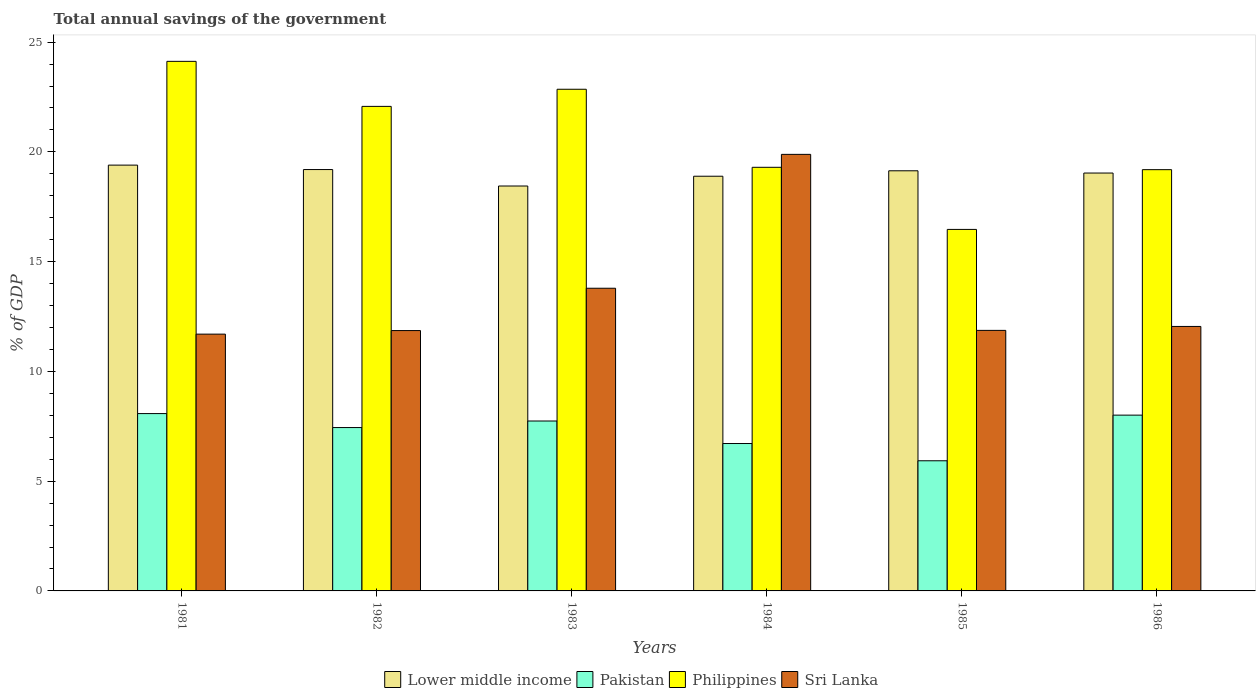How many groups of bars are there?
Give a very brief answer. 6. How many bars are there on the 6th tick from the left?
Ensure brevity in your answer.  4. How many bars are there on the 4th tick from the right?
Provide a short and direct response. 4. What is the label of the 1st group of bars from the left?
Your response must be concise. 1981. What is the total annual savings of the government in Philippines in 1985?
Your response must be concise. 16.47. Across all years, what is the maximum total annual savings of the government in Lower middle income?
Provide a succinct answer. 19.4. Across all years, what is the minimum total annual savings of the government in Philippines?
Your response must be concise. 16.47. In which year was the total annual savings of the government in Sri Lanka maximum?
Your answer should be compact. 1984. What is the total total annual savings of the government in Philippines in the graph?
Provide a short and direct response. 124.01. What is the difference between the total annual savings of the government in Pakistan in 1981 and that in 1985?
Provide a short and direct response. 2.15. What is the difference between the total annual savings of the government in Sri Lanka in 1986 and the total annual savings of the government in Philippines in 1983?
Your answer should be very brief. -10.8. What is the average total annual savings of the government in Philippines per year?
Give a very brief answer. 20.67. In the year 1986, what is the difference between the total annual savings of the government in Lower middle income and total annual savings of the government in Pakistan?
Your response must be concise. 11.03. In how many years, is the total annual savings of the government in Sri Lanka greater than 6 %?
Offer a very short reply. 6. What is the ratio of the total annual savings of the government in Philippines in 1981 to that in 1982?
Your answer should be very brief. 1.09. Is the total annual savings of the government in Philippines in 1983 less than that in 1986?
Your answer should be compact. No. Is the difference between the total annual savings of the government in Lower middle income in 1982 and 1984 greater than the difference between the total annual savings of the government in Pakistan in 1982 and 1984?
Provide a short and direct response. No. What is the difference between the highest and the second highest total annual savings of the government in Philippines?
Offer a very short reply. 1.27. What is the difference between the highest and the lowest total annual savings of the government in Sri Lanka?
Your response must be concise. 8.19. Is the sum of the total annual savings of the government in Pakistan in 1982 and 1984 greater than the maximum total annual savings of the government in Philippines across all years?
Your answer should be very brief. No. Is it the case that in every year, the sum of the total annual savings of the government in Pakistan and total annual savings of the government in Lower middle income is greater than the sum of total annual savings of the government in Sri Lanka and total annual savings of the government in Philippines?
Make the answer very short. Yes. What does the 3rd bar from the left in 1984 represents?
Offer a very short reply. Philippines. What does the 4th bar from the right in 1985 represents?
Provide a short and direct response. Lower middle income. How many years are there in the graph?
Make the answer very short. 6. Does the graph contain any zero values?
Offer a terse response. No. Where does the legend appear in the graph?
Offer a terse response. Bottom center. How are the legend labels stacked?
Provide a short and direct response. Horizontal. What is the title of the graph?
Ensure brevity in your answer.  Total annual savings of the government. What is the label or title of the Y-axis?
Keep it short and to the point. % of GDP. What is the % of GDP of Lower middle income in 1981?
Provide a succinct answer. 19.4. What is the % of GDP in Pakistan in 1981?
Make the answer very short. 8.08. What is the % of GDP of Philippines in 1981?
Provide a succinct answer. 24.12. What is the % of GDP in Sri Lanka in 1981?
Offer a terse response. 11.7. What is the % of GDP of Lower middle income in 1982?
Keep it short and to the point. 19.2. What is the % of GDP in Pakistan in 1982?
Give a very brief answer. 7.44. What is the % of GDP in Philippines in 1982?
Provide a succinct answer. 22.07. What is the % of GDP in Sri Lanka in 1982?
Provide a short and direct response. 11.86. What is the % of GDP in Lower middle income in 1983?
Your response must be concise. 18.45. What is the % of GDP of Pakistan in 1983?
Offer a terse response. 7.74. What is the % of GDP of Philippines in 1983?
Give a very brief answer. 22.85. What is the % of GDP in Sri Lanka in 1983?
Offer a very short reply. 13.79. What is the % of GDP in Lower middle income in 1984?
Offer a very short reply. 18.89. What is the % of GDP in Pakistan in 1984?
Give a very brief answer. 6.71. What is the % of GDP of Philippines in 1984?
Give a very brief answer. 19.3. What is the % of GDP of Sri Lanka in 1984?
Make the answer very short. 19.89. What is the % of GDP of Lower middle income in 1985?
Ensure brevity in your answer.  19.14. What is the % of GDP in Pakistan in 1985?
Keep it short and to the point. 5.93. What is the % of GDP of Philippines in 1985?
Offer a terse response. 16.47. What is the % of GDP of Sri Lanka in 1985?
Provide a succinct answer. 11.87. What is the % of GDP of Lower middle income in 1986?
Give a very brief answer. 19.04. What is the % of GDP of Pakistan in 1986?
Make the answer very short. 8.01. What is the % of GDP in Philippines in 1986?
Provide a succinct answer. 19.19. What is the % of GDP in Sri Lanka in 1986?
Make the answer very short. 12.05. Across all years, what is the maximum % of GDP in Lower middle income?
Provide a succinct answer. 19.4. Across all years, what is the maximum % of GDP of Pakistan?
Offer a very short reply. 8.08. Across all years, what is the maximum % of GDP of Philippines?
Your answer should be compact. 24.12. Across all years, what is the maximum % of GDP of Sri Lanka?
Provide a short and direct response. 19.89. Across all years, what is the minimum % of GDP of Lower middle income?
Offer a terse response. 18.45. Across all years, what is the minimum % of GDP of Pakistan?
Keep it short and to the point. 5.93. Across all years, what is the minimum % of GDP of Philippines?
Your response must be concise. 16.47. Across all years, what is the minimum % of GDP of Sri Lanka?
Your answer should be compact. 11.7. What is the total % of GDP in Lower middle income in the graph?
Give a very brief answer. 114.11. What is the total % of GDP in Pakistan in the graph?
Keep it short and to the point. 43.91. What is the total % of GDP in Philippines in the graph?
Provide a short and direct response. 124.01. What is the total % of GDP of Sri Lanka in the graph?
Your response must be concise. 81.15. What is the difference between the % of GDP of Lower middle income in 1981 and that in 1982?
Provide a short and direct response. 0.2. What is the difference between the % of GDP of Pakistan in 1981 and that in 1982?
Keep it short and to the point. 0.64. What is the difference between the % of GDP in Philippines in 1981 and that in 1982?
Your answer should be very brief. 2.05. What is the difference between the % of GDP in Sri Lanka in 1981 and that in 1982?
Keep it short and to the point. -0.16. What is the difference between the % of GDP in Lower middle income in 1981 and that in 1983?
Your response must be concise. 0.95. What is the difference between the % of GDP of Pakistan in 1981 and that in 1983?
Give a very brief answer. 0.34. What is the difference between the % of GDP in Philippines in 1981 and that in 1983?
Give a very brief answer. 1.27. What is the difference between the % of GDP of Sri Lanka in 1981 and that in 1983?
Your answer should be compact. -2.09. What is the difference between the % of GDP of Lower middle income in 1981 and that in 1984?
Give a very brief answer. 0.51. What is the difference between the % of GDP of Pakistan in 1981 and that in 1984?
Offer a very short reply. 1.36. What is the difference between the % of GDP of Philippines in 1981 and that in 1984?
Give a very brief answer. 4.83. What is the difference between the % of GDP in Sri Lanka in 1981 and that in 1984?
Keep it short and to the point. -8.19. What is the difference between the % of GDP in Lower middle income in 1981 and that in 1985?
Offer a terse response. 0.26. What is the difference between the % of GDP of Pakistan in 1981 and that in 1985?
Provide a short and direct response. 2.15. What is the difference between the % of GDP in Philippines in 1981 and that in 1985?
Your answer should be compact. 7.66. What is the difference between the % of GDP in Sri Lanka in 1981 and that in 1985?
Ensure brevity in your answer.  -0.17. What is the difference between the % of GDP in Lower middle income in 1981 and that in 1986?
Keep it short and to the point. 0.36. What is the difference between the % of GDP of Pakistan in 1981 and that in 1986?
Offer a very short reply. 0.07. What is the difference between the % of GDP of Philippines in 1981 and that in 1986?
Your answer should be compact. 4.93. What is the difference between the % of GDP of Sri Lanka in 1981 and that in 1986?
Your answer should be very brief. -0.35. What is the difference between the % of GDP of Lower middle income in 1982 and that in 1983?
Ensure brevity in your answer.  0.75. What is the difference between the % of GDP in Pakistan in 1982 and that in 1983?
Your answer should be very brief. -0.3. What is the difference between the % of GDP of Philippines in 1982 and that in 1983?
Provide a succinct answer. -0.78. What is the difference between the % of GDP of Sri Lanka in 1982 and that in 1983?
Give a very brief answer. -1.93. What is the difference between the % of GDP in Lower middle income in 1982 and that in 1984?
Offer a very short reply. 0.3. What is the difference between the % of GDP of Pakistan in 1982 and that in 1984?
Make the answer very short. 0.73. What is the difference between the % of GDP of Philippines in 1982 and that in 1984?
Offer a very short reply. 2.78. What is the difference between the % of GDP in Sri Lanka in 1982 and that in 1984?
Give a very brief answer. -8.03. What is the difference between the % of GDP in Lower middle income in 1982 and that in 1985?
Ensure brevity in your answer.  0.06. What is the difference between the % of GDP of Pakistan in 1982 and that in 1985?
Offer a terse response. 1.51. What is the difference between the % of GDP of Philippines in 1982 and that in 1985?
Offer a very short reply. 5.6. What is the difference between the % of GDP of Sri Lanka in 1982 and that in 1985?
Provide a short and direct response. -0.01. What is the difference between the % of GDP in Lower middle income in 1982 and that in 1986?
Offer a terse response. 0.16. What is the difference between the % of GDP in Pakistan in 1982 and that in 1986?
Keep it short and to the point. -0.57. What is the difference between the % of GDP in Philippines in 1982 and that in 1986?
Your response must be concise. 2.88. What is the difference between the % of GDP in Sri Lanka in 1982 and that in 1986?
Provide a short and direct response. -0.19. What is the difference between the % of GDP in Lower middle income in 1983 and that in 1984?
Offer a terse response. -0.45. What is the difference between the % of GDP in Pakistan in 1983 and that in 1984?
Your answer should be compact. 1.03. What is the difference between the % of GDP in Philippines in 1983 and that in 1984?
Offer a terse response. 3.56. What is the difference between the % of GDP of Sri Lanka in 1983 and that in 1984?
Provide a succinct answer. -6.1. What is the difference between the % of GDP in Lower middle income in 1983 and that in 1985?
Your answer should be very brief. -0.69. What is the difference between the % of GDP of Pakistan in 1983 and that in 1985?
Offer a terse response. 1.81. What is the difference between the % of GDP of Philippines in 1983 and that in 1985?
Keep it short and to the point. 6.38. What is the difference between the % of GDP in Sri Lanka in 1983 and that in 1985?
Give a very brief answer. 1.92. What is the difference between the % of GDP of Lower middle income in 1983 and that in 1986?
Your response must be concise. -0.59. What is the difference between the % of GDP in Pakistan in 1983 and that in 1986?
Your answer should be very brief. -0.27. What is the difference between the % of GDP in Philippines in 1983 and that in 1986?
Offer a terse response. 3.66. What is the difference between the % of GDP of Sri Lanka in 1983 and that in 1986?
Ensure brevity in your answer.  1.74. What is the difference between the % of GDP in Lower middle income in 1984 and that in 1985?
Keep it short and to the point. -0.25. What is the difference between the % of GDP in Pakistan in 1984 and that in 1985?
Offer a very short reply. 0.79. What is the difference between the % of GDP of Philippines in 1984 and that in 1985?
Provide a succinct answer. 2.83. What is the difference between the % of GDP in Sri Lanka in 1984 and that in 1985?
Your answer should be very brief. 8.02. What is the difference between the % of GDP of Lower middle income in 1984 and that in 1986?
Provide a succinct answer. -0.14. What is the difference between the % of GDP of Pakistan in 1984 and that in 1986?
Ensure brevity in your answer.  -1.29. What is the difference between the % of GDP in Philippines in 1984 and that in 1986?
Give a very brief answer. 0.11. What is the difference between the % of GDP of Sri Lanka in 1984 and that in 1986?
Your response must be concise. 7.84. What is the difference between the % of GDP of Lower middle income in 1985 and that in 1986?
Make the answer very short. 0.1. What is the difference between the % of GDP in Pakistan in 1985 and that in 1986?
Offer a very short reply. -2.08. What is the difference between the % of GDP in Philippines in 1985 and that in 1986?
Give a very brief answer. -2.72. What is the difference between the % of GDP in Sri Lanka in 1985 and that in 1986?
Ensure brevity in your answer.  -0.18. What is the difference between the % of GDP of Lower middle income in 1981 and the % of GDP of Pakistan in 1982?
Give a very brief answer. 11.96. What is the difference between the % of GDP in Lower middle income in 1981 and the % of GDP in Philippines in 1982?
Give a very brief answer. -2.68. What is the difference between the % of GDP of Lower middle income in 1981 and the % of GDP of Sri Lanka in 1982?
Your response must be concise. 7.54. What is the difference between the % of GDP of Pakistan in 1981 and the % of GDP of Philippines in 1982?
Your answer should be compact. -13.99. What is the difference between the % of GDP in Pakistan in 1981 and the % of GDP in Sri Lanka in 1982?
Make the answer very short. -3.78. What is the difference between the % of GDP of Philippines in 1981 and the % of GDP of Sri Lanka in 1982?
Keep it short and to the point. 12.26. What is the difference between the % of GDP in Lower middle income in 1981 and the % of GDP in Pakistan in 1983?
Make the answer very short. 11.66. What is the difference between the % of GDP in Lower middle income in 1981 and the % of GDP in Philippines in 1983?
Provide a succinct answer. -3.46. What is the difference between the % of GDP of Lower middle income in 1981 and the % of GDP of Sri Lanka in 1983?
Provide a short and direct response. 5.61. What is the difference between the % of GDP in Pakistan in 1981 and the % of GDP in Philippines in 1983?
Offer a terse response. -14.77. What is the difference between the % of GDP of Pakistan in 1981 and the % of GDP of Sri Lanka in 1983?
Your answer should be compact. -5.71. What is the difference between the % of GDP in Philippines in 1981 and the % of GDP in Sri Lanka in 1983?
Your response must be concise. 10.34. What is the difference between the % of GDP in Lower middle income in 1981 and the % of GDP in Pakistan in 1984?
Provide a short and direct response. 12.68. What is the difference between the % of GDP of Lower middle income in 1981 and the % of GDP of Philippines in 1984?
Keep it short and to the point. 0.1. What is the difference between the % of GDP in Lower middle income in 1981 and the % of GDP in Sri Lanka in 1984?
Ensure brevity in your answer.  -0.49. What is the difference between the % of GDP in Pakistan in 1981 and the % of GDP in Philippines in 1984?
Provide a short and direct response. -11.22. What is the difference between the % of GDP of Pakistan in 1981 and the % of GDP of Sri Lanka in 1984?
Your answer should be compact. -11.81. What is the difference between the % of GDP of Philippines in 1981 and the % of GDP of Sri Lanka in 1984?
Your response must be concise. 4.24. What is the difference between the % of GDP of Lower middle income in 1981 and the % of GDP of Pakistan in 1985?
Your response must be concise. 13.47. What is the difference between the % of GDP in Lower middle income in 1981 and the % of GDP in Philippines in 1985?
Offer a very short reply. 2.93. What is the difference between the % of GDP in Lower middle income in 1981 and the % of GDP in Sri Lanka in 1985?
Provide a succinct answer. 7.53. What is the difference between the % of GDP of Pakistan in 1981 and the % of GDP of Philippines in 1985?
Keep it short and to the point. -8.39. What is the difference between the % of GDP in Pakistan in 1981 and the % of GDP in Sri Lanka in 1985?
Offer a terse response. -3.79. What is the difference between the % of GDP in Philippines in 1981 and the % of GDP in Sri Lanka in 1985?
Provide a short and direct response. 12.26. What is the difference between the % of GDP in Lower middle income in 1981 and the % of GDP in Pakistan in 1986?
Your response must be concise. 11.39. What is the difference between the % of GDP in Lower middle income in 1981 and the % of GDP in Philippines in 1986?
Offer a terse response. 0.21. What is the difference between the % of GDP of Lower middle income in 1981 and the % of GDP of Sri Lanka in 1986?
Your answer should be compact. 7.35. What is the difference between the % of GDP of Pakistan in 1981 and the % of GDP of Philippines in 1986?
Your answer should be compact. -11.11. What is the difference between the % of GDP of Pakistan in 1981 and the % of GDP of Sri Lanka in 1986?
Provide a short and direct response. -3.97. What is the difference between the % of GDP in Philippines in 1981 and the % of GDP in Sri Lanka in 1986?
Offer a terse response. 12.08. What is the difference between the % of GDP in Lower middle income in 1982 and the % of GDP in Pakistan in 1983?
Your answer should be very brief. 11.46. What is the difference between the % of GDP of Lower middle income in 1982 and the % of GDP of Philippines in 1983?
Your answer should be compact. -3.66. What is the difference between the % of GDP of Lower middle income in 1982 and the % of GDP of Sri Lanka in 1983?
Offer a very short reply. 5.41. What is the difference between the % of GDP of Pakistan in 1982 and the % of GDP of Philippines in 1983?
Your answer should be very brief. -15.41. What is the difference between the % of GDP of Pakistan in 1982 and the % of GDP of Sri Lanka in 1983?
Your response must be concise. -6.35. What is the difference between the % of GDP of Philippines in 1982 and the % of GDP of Sri Lanka in 1983?
Provide a succinct answer. 8.29. What is the difference between the % of GDP of Lower middle income in 1982 and the % of GDP of Pakistan in 1984?
Offer a very short reply. 12.48. What is the difference between the % of GDP of Lower middle income in 1982 and the % of GDP of Philippines in 1984?
Your answer should be very brief. -0.1. What is the difference between the % of GDP in Lower middle income in 1982 and the % of GDP in Sri Lanka in 1984?
Your response must be concise. -0.69. What is the difference between the % of GDP in Pakistan in 1982 and the % of GDP in Philippines in 1984?
Your response must be concise. -11.86. What is the difference between the % of GDP in Pakistan in 1982 and the % of GDP in Sri Lanka in 1984?
Ensure brevity in your answer.  -12.45. What is the difference between the % of GDP of Philippines in 1982 and the % of GDP of Sri Lanka in 1984?
Ensure brevity in your answer.  2.19. What is the difference between the % of GDP in Lower middle income in 1982 and the % of GDP in Pakistan in 1985?
Make the answer very short. 13.27. What is the difference between the % of GDP of Lower middle income in 1982 and the % of GDP of Philippines in 1985?
Give a very brief answer. 2.73. What is the difference between the % of GDP in Lower middle income in 1982 and the % of GDP in Sri Lanka in 1985?
Ensure brevity in your answer.  7.33. What is the difference between the % of GDP of Pakistan in 1982 and the % of GDP of Philippines in 1985?
Your answer should be very brief. -9.03. What is the difference between the % of GDP in Pakistan in 1982 and the % of GDP in Sri Lanka in 1985?
Provide a succinct answer. -4.43. What is the difference between the % of GDP of Philippines in 1982 and the % of GDP of Sri Lanka in 1985?
Keep it short and to the point. 10.2. What is the difference between the % of GDP in Lower middle income in 1982 and the % of GDP in Pakistan in 1986?
Give a very brief answer. 11.19. What is the difference between the % of GDP of Lower middle income in 1982 and the % of GDP of Philippines in 1986?
Give a very brief answer. 0. What is the difference between the % of GDP of Lower middle income in 1982 and the % of GDP of Sri Lanka in 1986?
Provide a short and direct response. 7.15. What is the difference between the % of GDP of Pakistan in 1982 and the % of GDP of Philippines in 1986?
Provide a succinct answer. -11.75. What is the difference between the % of GDP in Pakistan in 1982 and the % of GDP in Sri Lanka in 1986?
Offer a very short reply. -4.61. What is the difference between the % of GDP of Philippines in 1982 and the % of GDP of Sri Lanka in 1986?
Keep it short and to the point. 10.03. What is the difference between the % of GDP of Lower middle income in 1983 and the % of GDP of Pakistan in 1984?
Give a very brief answer. 11.73. What is the difference between the % of GDP of Lower middle income in 1983 and the % of GDP of Philippines in 1984?
Your answer should be very brief. -0.85. What is the difference between the % of GDP of Lower middle income in 1983 and the % of GDP of Sri Lanka in 1984?
Make the answer very short. -1.44. What is the difference between the % of GDP of Pakistan in 1983 and the % of GDP of Philippines in 1984?
Ensure brevity in your answer.  -11.56. What is the difference between the % of GDP in Pakistan in 1983 and the % of GDP in Sri Lanka in 1984?
Provide a succinct answer. -12.15. What is the difference between the % of GDP in Philippines in 1983 and the % of GDP in Sri Lanka in 1984?
Provide a succinct answer. 2.97. What is the difference between the % of GDP in Lower middle income in 1983 and the % of GDP in Pakistan in 1985?
Your answer should be very brief. 12.52. What is the difference between the % of GDP of Lower middle income in 1983 and the % of GDP of Philippines in 1985?
Offer a very short reply. 1.98. What is the difference between the % of GDP in Lower middle income in 1983 and the % of GDP in Sri Lanka in 1985?
Keep it short and to the point. 6.58. What is the difference between the % of GDP in Pakistan in 1983 and the % of GDP in Philippines in 1985?
Provide a short and direct response. -8.73. What is the difference between the % of GDP in Pakistan in 1983 and the % of GDP in Sri Lanka in 1985?
Your response must be concise. -4.13. What is the difference between the % of GDP in Philippines in 1983 and the % of GDP in Sri Lanka in 1985?
Give a very brief answer. 10.98. What is the difference between the % of GDP of Lower middle income in 1983 and the % of GDP of Pakistan in 1986?
Offer a very short reply. 10.44. What is the difference between the % of GDP of Lower middle income in 1983 and the % of GDP of Philippines in 1986?
Provide a succinct answer. -0.74. What is the difference between the % of GDP in Lower middle income in 1983 and the % of GDP in Sri Lanka in 1986?
Offer a very short reply. 6.4. What is the difference between the % of GDP in Pakistan in 1983 and the % of GDP in Philippines in 1986?
Keep it short and to the point. -11.45. What is the difference between the % of GDP of Pakistan in 1983 and the % of GDP of Sri Lanka in 1986?
Offer a terse response. -4.31. What is the difference between the % of GDP in Philippines in 1983 and the % of GDP in Sri Lanka in 1986?
Your answer should be very brief. 10.8. What is the difference between the % of GDP in Lower middle income in 1984 and the % of GDP in Pakistan in 1985?
Offer a terse response. 12.96. What is the difference between the % of GDP of Lower middle income in 1984 and the % of GDP of Philippines in 1985?
Ensure brevity in your answer.  2.42. What is the difference between the % of GDP of Lower middle income in 1984 and the % of GDP of Sri Lanka in 1985?
Offer a very short reply. 7.02. What is the difference between the % of GDP in Pakistan in 1984 and the % of GDP in Philippines in 1985?
Make the answer very short. -9.75. What is the difference between the % of GDP of Pakistan in 1984 and the % of GDP of Sri Lanka in 1985?
Keep it short and to the point. -5.15. What is the difference between the % of GDP of Philippines in 1984 and the % of GDP of Sri Lanka in 1985?
Keep it short and to the point. 7.43. What is the difference between the % of GDP of Lower middle income in 1984 and the % of GDP of Pakistan in 1986?
Your response must be concise. 10.88. What is the difference between the % of GDP of Lower middle income in 1984 and the % of GDP of Philippines in 1986?
Your answer should be very brief. -0.3. What is the difference between the % of GDP of Lower middle income in 1984 and the % of GDP of Sri Lanka in 1986?
Offer a terse response. 6.84. What is the difference between the % of GDP in Pakistan in 1984 and the % of GDP in Philippines in 1986?
Provide a succinct answer. -12.48. What is the difference between the % of GDP of Pakistan in 1984 and the % of GDP of Sri Lanka in 1986?
Provide a short and direct response. -5.33. What is the difference between the % of GDP of Philippines in 1984 and the % of GDP of Sri Lanka in 1986?
Your response must be concise. 7.25. What is the difference between the % of GDP of Lower middle income in 1985 and the % of GDP of Pakistan in 1986?
Your response must be concise. 11.13. What is the difference between the % of GDP in Lower middle income in 1985 and the % of GDP in Philippines in 1986?
Give a very brief answer. -0.05. What is the difference between the % of GDP of Lower middle income in 1985 and the % of GDP of Sri Lanka in 1986?
Ensure brevity in your answer.  7.09. What is the difference between the % of GDP of Pakistan in 1985 and the % of GDP of Philippines in 1986?
Ensure brevity in your answer.  -13.26. What is the difference between the % of GDP in Pakistan in 1985 and the % of GDP in Sri Lanka in 1986?
Your answer should be compact. -6.12. What is the difference between the % of GDP of Philippines in 1985 and the % of GDP of Sri Lanka in 1986?
Your answer should be very brief. 4.42. What is the average % of GDP of Lower middle income per year?
Provide a succinct answer. 19.02. What is the average % of GDP of Pakistan per year?
Offer a terse response. 7.32. What is the average % of GDP of Philippines per year?
Offer a very short reply. 20.67. What is the average % of GDP in Sri Lanka per year?
Offer a very short reply. 13.53. In the year 1981, what is the difference between the % of GDP in Lower middle income and % of GDP in Pakistan?
Your response must be concise. 11.32. In the year 1981, what is the difference between the % of GDP in Lower middle income and % of GDP in Philippines?
Provide a succinct answer. -4.73. In the year 1981, what is the difference between the % of GDP in Lower middle income and % of GDP in Sri Lanka?
Provide a succinct answer. 7.7. In the year 1981, what is the difference between the % of GDP in Pakistan and % of GDP in Philippines?
Make the answer very short. -16.05. In the year 1981, what is the difference between the % of GDP in Pakistan and % of GDP in Sri Lanka?
Give a very brief answer. -3.62. In the year 1981, what is the difference between the % of GDP of Philippines and % of GDP of Sri Lanka?
Ensure brevity in your answer.  12.43. In the year 1982, what is the difference between the % of GDP in Lower middle income and % of GDP in Pakistan?
Your response must be concise. 11.75. In the year 1982, what is the difference between the % of GDP of Lower middle income and % of GDP of Philippines?
Make the answer very short. -2.88. In the year 1982, what is the difference between the % of GDP in Lower middle income and % of GDP in Sri Lanka?
Ensure brevity in your answer.  7.34. In the year 1982, what is the difference between the % of GDP of Pakistan and % of GDP of Philippines?
Your response must be concise. -14.63. In the year 1982, what is the difference between the % of GDP of Pakistan and % of GDP of Sri Lanka?
Provide a succinct answer. -4.42. In the year 1982, what is the difference between the % of GDP of Philippines and % of GDP of Sri Lanka?
Your answer should be compact. 10.21. In the year 1983, what is the difference between the % of GDP of Lower middle income and % of GDP of Pakistan?
Your answer should be compact. 10.71. In the year 1983, what is the difference between the % of GDP of Lower middle income and % of GDP of Philippines?
Your response must be concise. -4.41. In the year 1983, what is the difference between the % of GDP in Lower middle income and % of GDP in Sri Lanka?
Ensure brevity in your answer.  4.66. In the year 1983, what is the difference between the % of GDP of Pakistan and % of GDP of Philippines?
Your answer should be very brief. -15.11. In the year 1983, what is the difference between the % of GDP of Pakistan and % of GDP of Sri Lanka?
Provide a short and direct response. -6.05. In the year 1983, what is the difference between the % of GDP in Philippines and % of GDP in Sri Lanka?
Offer a terse response. 9.06. In the year 1984, what is the difference between the % of GDP in Lower middle income and % of GDP in Pakistan?
Make the answer very short. 12.18. In the year 1984, what is the difference between the % of GDP in Lower middle income and % of GDP in Philippines?
Provide a succinct answer. -0.41. In the year 1984, what is the difference between the % of GDP in Lower middle income and % of GDP in Sri Lanka?
Your answer should be very brief. -1. In the year 1984, what is the difference between the % of GDP of Pakistan and % of GDP of Philippines?
Provide a short and direct response. -12.58. In the year 1984, what is the difference between the % of GDP of Pakistan and % of GDP of Sri Lanka?
Your answer should be compact. -13.17. In the year 1984, what is the difference between the % of GDP in Philippines and % of GDP in Sri Lanka?
Give a very brief answer. -0.59. In the year 1985, what is the difference between the % of GDP of Lower middle income and % of GDP of Pakistan?
Make the answer very short. 13.21. In the year 1985, what is the difference between the % of GDP of Lower middle income and % of GDP of Philippines?
Offer a very short reply. 2.67. In the year 1985, what is the difference between the % of GDP in Lower middle income and % of GDP in Sri Lanka?
Provide a succinct answer. 7.27. In the year 1985, what is the difference between the % of GDP of Pakistan and % of GDP of Philippines?
Keep it short and to the point. -10.54. In the year 1985, what is the difference between the % of GDP of Pakistan and % of GDP of Sri Lanka?
Offer a very short reply. -5.94. In the year 1985, what is the difference between the % of GDP of Philippines and % of GDP of Sri Lanka?
Make the answer very short. 4.6. In the year 1986, what is the difference between the % of GDP of Lower middle income and % of GDP of Pakistan?
Your answer should be compact. 11.03. In the year 1986, what is the difference between the % of GDP in Lower middle income and % of GDP in Philippines?
Provide a succinct answer. -0.15. In the year 1986, what is the difference between the % of GDP in Lower middle income and % of GDP in Sri Lanka?
Your answer should be compact. 6.99. In the year 1986, what is the difference between the % of GDP in Pakistan and % of GDP in Philippines?
Ensure brevity in your answer.  -11.18. In the year 1986, what is the difference between the % of GDP in Pakistan and % of GDP in Sri Lanka?
Your answer should be very brief. -4.04. In the year 1986, what is the difference between the % of GDP of Philippines and % of GDP of Sri Lanka?
Provide a short and direct response. 7.14. What is the ratio of the % of GDP of Lower middle income in 1981 to that in 1982?
Provide a succinct answer. 1.01. What is the ratio of the % of GDP in Pakistan in 1981 to that in 1982?
Make the answer very short. 1.09. What is the ratio of the % of GDP in Philippines in 1981 to that in 1982?
Keep it short and to the point. 1.09. What is the ratio of the % of GDP in Sri Lanka in 1981 to that in 1982?
Your answer should be compact. 0.99. What is the ratio of the % of GDP in Lower middle income in 1981 to that in 1983?
Ensure brevity in your answer.  1.05. What is the ratio of the % of GDP in Pakistan in 1981 to that in 1983?
Your response must be concise. 1.04. What is the ratio of the % of GDP of Philippines in 1981 to that in 1983?
Provide a succinct answer. 1.06. What is the ratio of the % of GDP in Sri Lanka in 1981 to that in 1983?
Offer a very short reply. 0.85. What is the ratio of the % of GDP of Lower middle income in 1981 to that in 1984?
Your response must be concise. 1.03. What is the ratio of the % of GDP in Pakistan in 1981 to that in 1984?
Provide a succinct answer. 1.2. What is the ratio of the % of GDP in Philippines in 1981 to that in 1984?
Provide a short and direct response. 1.25. What is the ratio of the % of GDP of Sri Lanka in 1981 to that in 1984?
Your answer should be compact. 0.59. What is the ratio of the % of GDP in Lower middle income in 1981 to that in 1985?
Make the answer very short. 1.01. What is the ratio of the % of GDP of Pakistan in 1981 to that in 1985?
Give a very brief answer. 1.36. What is the ratio of the % of GDP of Philippines in 1981 to that in 1985?
Offer a very short reply. 1.46. What is the ratio of the % of GDP in Sri Lanka in 1981 to that in 1985?
Ensure brevity in your answer.  0.99. What is the ratio of the % of GDP of Lower middle income in 1981 to that in 1986?
Provide a short and direct response. 1.02. What is the ratio of the % of GDP of Pakistan in 1981 to that in 1986?
Keep it short and to the point. 1.01. What is the ratio of the % of GDP in Philippines in 1981 to that in 1986?
Your response must be concise. 1.26. What is the ratio of the % of GDP of Sri Lanka in 1981 to that in 1986?
Your answer should be very brief. 0.97. What is the ratio of the % of GDP in Lower middle income in 1982 to that in 1983?
Make the answer very short. 1.04. What is the ratio of the % of GDP of Pakistan in 1982 to that in 1983?
Provide a succinct answer. 0.96. What is the ratio of the % of GDP in Philippines in 1982 to that in 1983?
Your answer should be very brief. 0.97. What is the ratio of the % of GDP of Sri Lanka in 1982 to that in 1983?
Offer a terse response. 0.86. What is the ratio of the % of GDP in Lower middle income in 1982 to that in 1984?
Make the answer very short. 1.02. What is the ratio of the % of GDP of Pakistan in 1982 to that in 1984?
Ensure brevity in your answer.  1.11. What is the ratio of the % of GDP of Philippines in 1982 to that in 1984?
Offer a terse response. 1.14. What is the ratio of the % of GDP in Sri Lanka in 1982 to that in 1984?
Give a very brief answer. 0.6. What is the ratio of the % of GDP of Pakistan in 1982 to that in 1985?
Your response must be concise. 1.26. What is the ratio of the % of GDP of Philippines in 1982 to that in 1985?
Make the answer very short. 1.34. What is the ratio of the % of GDP in Lower middle income in 1982 to that in 1986?
Make the answer very short. 1.01. What is the ratio of the % of GDP of Pakistan in 1982 to that in 1986?
Offer a terse response. 0.93. What is the ratio of the % of GDP of Philippines in 1982 to that in 1986?
Give a very brief answer. 1.15. What is the ratio of the % of GDP of Sri Lanka in 1982 to that in 1986?
Offer a terse response. 0.98. What is the ratio of the % of GDP in Lower middle income in 1983 to that in 1984?
Provide a short and direct response. 0.98. What is the ratio of the % of GDP in Pakistan in 1983 to that in 1984?
Offer a very short reply. 1.15. What is the ratio of the % of GDP of Philippines in 1983 to that in 1984?
Your response must be concise. 1.18. What is the ratio of the % of GDP in Sri Lanka in 1983 to that in 1984?
Provide a succinct answer. 0.69. What is the ratio of the % of GDP in Lower middle income in 1983 to that in 1985?
Make the answer very short. 0.96. What is the ratio of the % of GDP of Pakistan in 1983 to that in 1985?
Your response must be concise. 1.31. What is the ratio of the % of GDP in Philippines in 1983 to that in 1985?
Offer a terse response. 1.39. What is the ratio of the % of GDP of Sri Lanka in 1983 to that in 1985?
Your response must be concise. 1.16. What is the ratio of the % of GDP in Lower middle income in 1983 to that in 1986?
Keep it short and to the point. 0.97. What is the ratio of the % of GDP in Pakistan in 1983 to that in 1986?
Your answer should be compact. 0.97. What is the ratio of the % of GDP in Philippines in 1983 to that in 1986?
Offer a very short reply. 1.19. What is the ratio of the % of GDP in Sri Lanka in 1983 to that in 1986?
Provide a short and direct response. 1.14. What is the ratio of the % of GDP of Lower middle income in 1984 to that in 1985?
Give a very brief answer. 0.99. What is the ratio of the % of GDP in Pakistan in 1984 to that in 1985?
Your answer should be very brief. 1.13. What is the ratio of the % of GDP of Philippines in 1984 to that in 1985?
Your answer should be very brief. 1.17. What is the ratio of the % of GDP of Sri Lanka in 1984 to that in 1985?
Provide a short and direct response. 1.68. What is the ratio of the % of GDP of Pakistan in 1984 to that in 1986?
Give a very brief answer. 0.84. What is the ratio of the % of GDP in Philippines in 1984 to that in 1986?
Provide a succinct answer. 1.01. What is the ratio of the % of GDP in Sri Lanka in 1984 to that in 1986?
Your response must be concise. 1.65. What is the ratio of the % of GDP in Lower middle income in 1985 to that in 1986?
Provide a short and direct response. 1.01. What is the ratio of the % of GDP in Pakistan in 1985 to that in 1986?
Make the answer very short. 0.74. What is the ratio of the % of GDP in Philippines in 1985 to that in 1986?
Make the answer very short. 0.86. What is the ratio of the % of GDP in Sri Lanka in 1985 to that in 1986?
Provide a short and direct response. 0.99. What is the difference between the highest and the second highest % of GDP in Lower middle income?
Give a very brief answer. 0.2. What is the difference between the highest and the second highest % of GDP in Pakistan?
Provide a short and direct response. 0.07. What is the difference between the highest and the second highest % of GDP in Philippines?
Make the answer very short. 1.27. What is the difference between the highest and the second highest % of GDP in Sri Lanka?
Your answer should be very brief. 6.1. What is the difference between the highest and the lowest % of GDP in Lower middle income?
Offer a terse response. 0.95. What is the difference between the highest and the lowest % of GDP in Pakistan?
Offer a very short reply. 2.15. What is the difference between the highest and the lowest % of GDP of Philippines?
Offer a very short reply. 7.66. What is the difference between the highest and the lowest % of GDP of Sri Lanka?
Your answer should be compact. 8.19. 